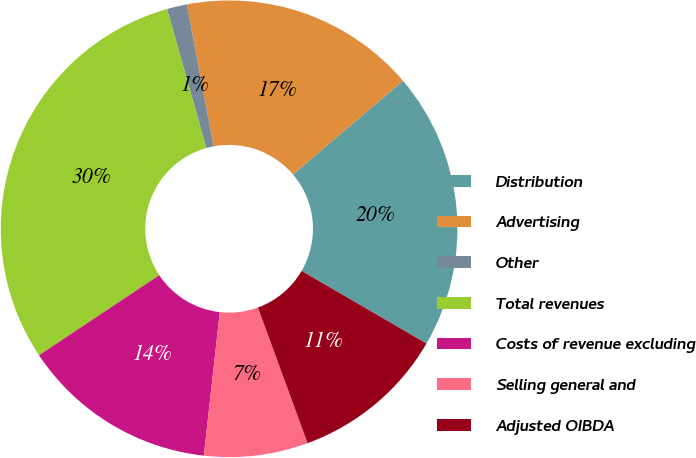Convert chart. <chart><loc_0><loc_0><loc_500><loc_500><pie_chart><fcel>Distribution<fcel>Advertising<fcel>Other<fcel>Total revenues<fcel>Costs of revenue excluding<fcel>Selling general and<fcel>Adjusted OIBDA<nl><fcel>19.6%<fcel>16.74%<fcel>1.42%<fcel>29.96%<fcel>13.89%<fcel>7.35%<fcel>11.03%<nl></chart> 